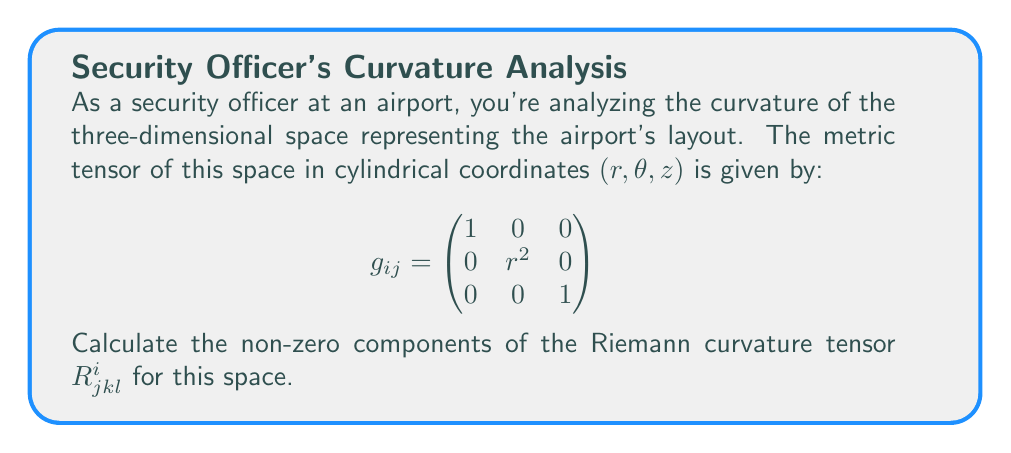Solve this math problem. To calculate the Riemann curvature tensor, we'll follow these steps:

1) First, we need to calculate the Christoffel symbols $\Gamma^i_{jk}$ using the metric tensor:

   $$\Gamma^i_{jk} = \frac{1}{2}g^{im}(\partial_j g_{km} + \partial_k g_{jm} - \partial_m g_{jk})$$

2) The non-zero Christoffel symbols for this metric are:
   
   $$\Gamma^r_{\theta\theta} = -r$$
   $$\Gamma^\theta_{r\theta} = \Gamma^\theta_{\theta r} = \frac{1}{r}$$

3) Now, we can use the Riemann tensor formula:

   $$R^i_{jkl} = \partial_k \Gamma^i_{jl} - \partial_l \Gamma^i_{jk} + \Gamma^m_{jl}\Gamma^i_{km} - \Gamma^m_{jk}\Gamma^i_{lm}$$

4) Calculating the non-zero components:

   $$R^r_{\theta r \theta} = \partial_r \Gamma^r_{\theta\theta} - \partial_\theta \Gamma^r_{r\theta} + \Gamma^m_{\theta\theta}\Gamma^r_{rm} - \Gamma^m_{r\theta}\Gamma^r_{\theta m}$$
   $$= \partial_r (-r) - 0 + 0 - \Gamma^\theta_{r\theta}\Gamma^r_{\theta \theta}$$
   $$= -1 - \frac{1}{r}(-r) = -1 + 1 = 0$$

   $$R^\theta_{r\theta r} = \partial_\theta \Gamma^\theta_{rr} - \partial_r \Gamma^\theta_{r\theta} + \Gamma^m_{rr}\Gamma^\theta_{\theta m} - \Gamma^m_{r\theta}\Gamma^\theta_{rm}$$
   $$= 0 - \partial_r (\frac{1}{r}) + 0 - \Gamma^\theta_{r\theta}\Gamma^\theta_{r\theta}$$
   $$= \frac{1}{r^2} - (\frac{1}{r})^2 = 0$$

5) All other components are zero due to the symmetries of the Riemann tensor.

Therefore, the Riemann curvature tensor for this space is identically zero, indicating that the space is flat.
Answer: $R^i_{jkl} = 0$ for all $i,j,k,l$ 